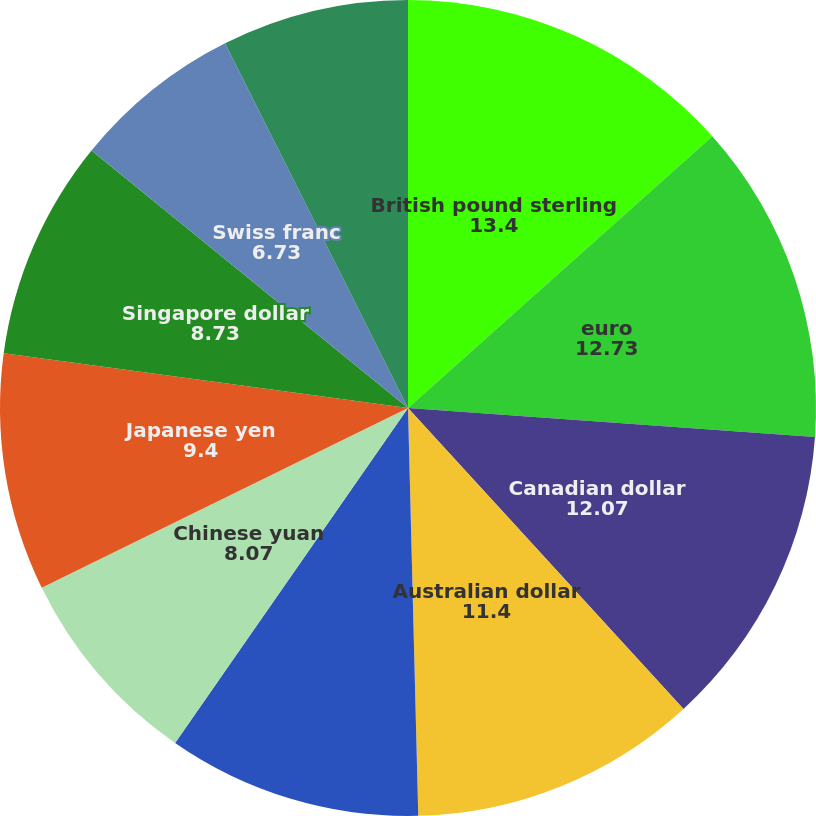Convert chart. <chart><loc_0><loc_0><loc_500><loc_500><pie_chart><fcel>British pound sterling<fcel>euro<fcel>Canadian dollar<fcel>Australian dollar<fcel>Indian rupee<fcel>Chinese yuan<fcel>Japanese yen<fcel>Singapore dollar<fcel>Swiss franc<fcel>Brazilian real<nl><fcel>13.4%<fcel>12.73%<fcel>12.07%<fcel>11.4%<fcel>10.07%<fcel>8.07%<fcel>9.4%<fcel>8.73%<fcel>6.73%<fcel>7.4%<nl></chart> 